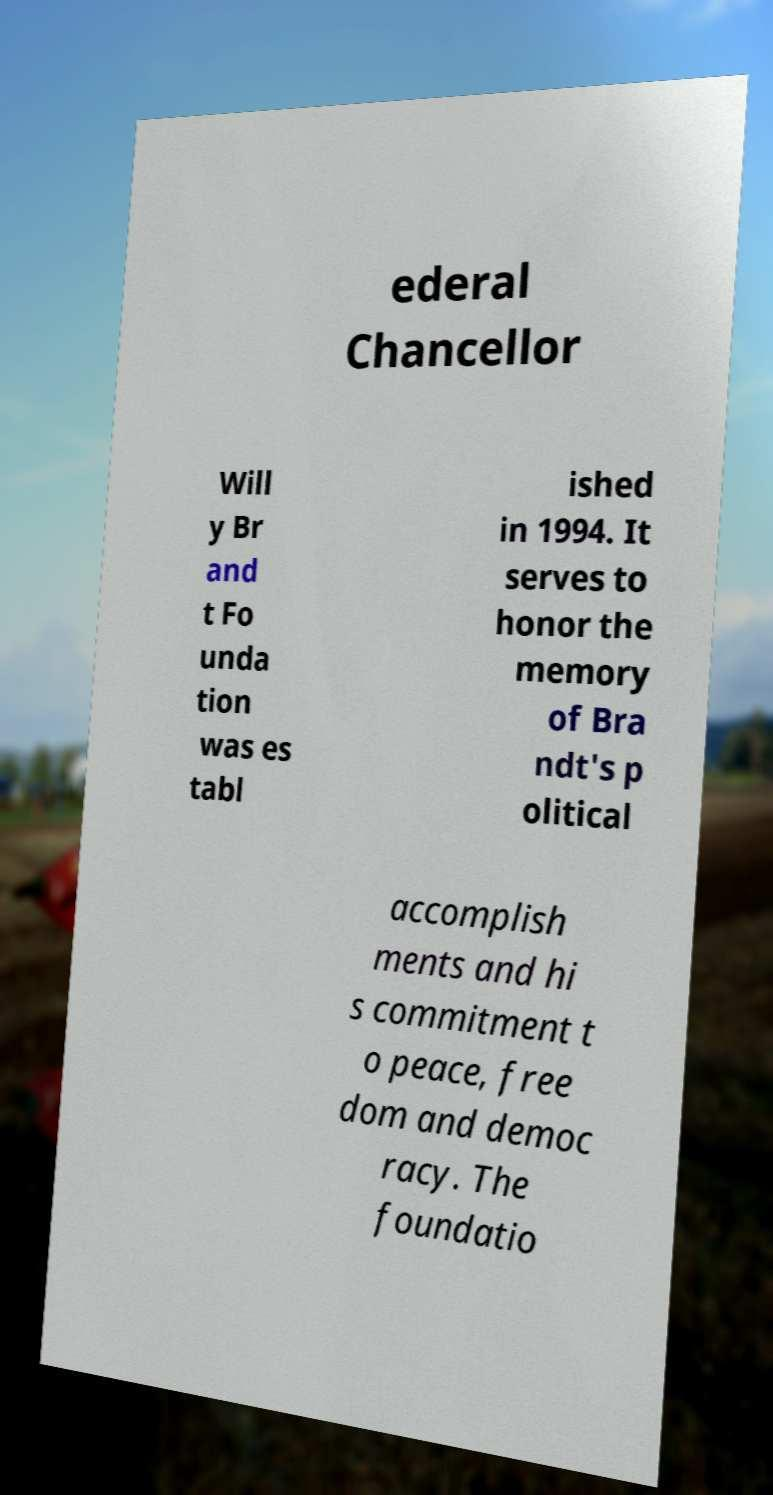There's text embedded in this image that I need extracted. Can you transcribe it verbatim? ederal Chancellor Will y Br and t Fo unda tion was es tabl ished in 1994. It serves to honor the memory of Bra ndt's p olitical accomplish ments and hi s commitment t o peace, free dom and democ racy. The foundatio 